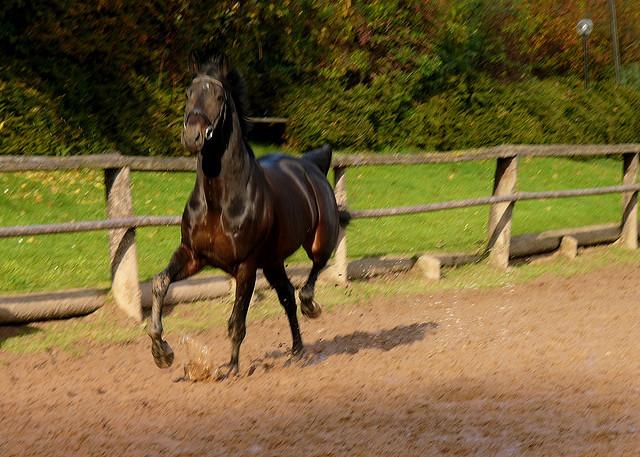What is the color of the horses hooves?
Answer briefly. Brown. Could this animal break the gate?
Write a very short answer. Yes. What kind of animal is running?
Quick response, please. Horse. Is the track muddy?
Be succinct. Yes. Are this people racing or horses are running?
Be succinct. Running. What is the horse running on?
Write a very short answer. Mud. 